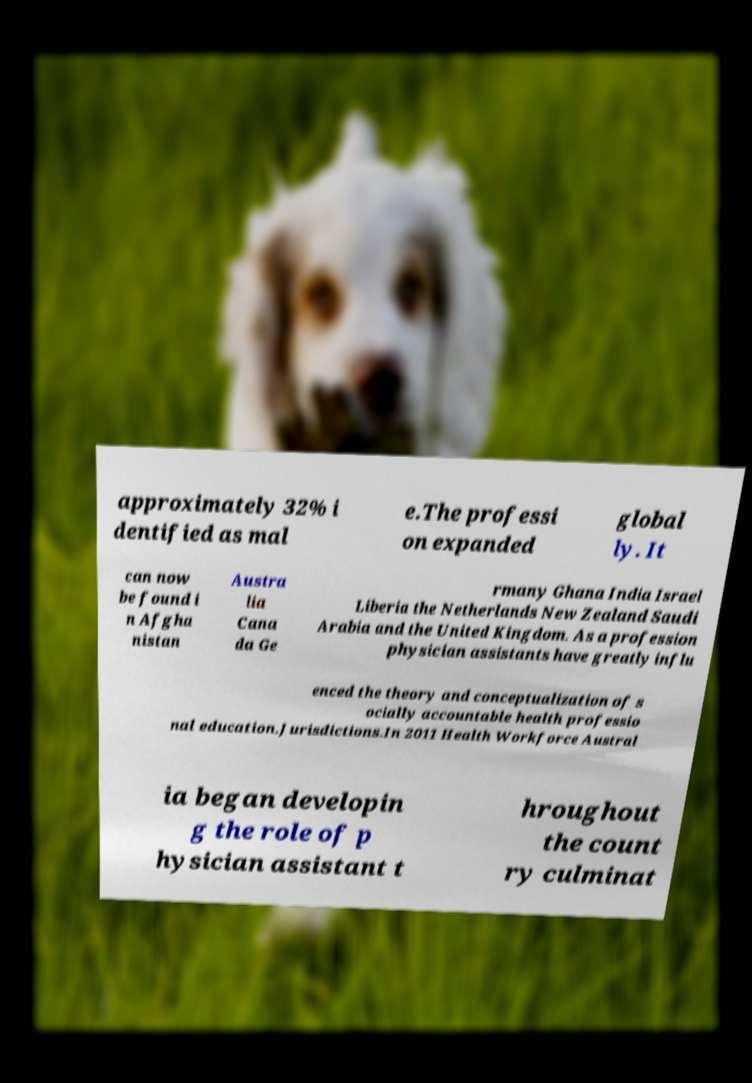For documentation purposes, I need the text within this image transcribed. Could you provide that? approximately 32% i dentified as mal e.The professi on expanded global ly. It can now be found i n Afgha nistan Austra lia Cana da Ge rmany Ghana India Israel Liberia the Netherlands New Zealand Saudi Arabia and the United Kingdom. As a profession physician assistants have greatly influ enced the theory and conceptualization of s ocially accountable health professio nal education.Jurisdictions.In 2011 Health Workforce Austral ia began developin g the role of p hysician assistant t hroughout the count ry culminat 